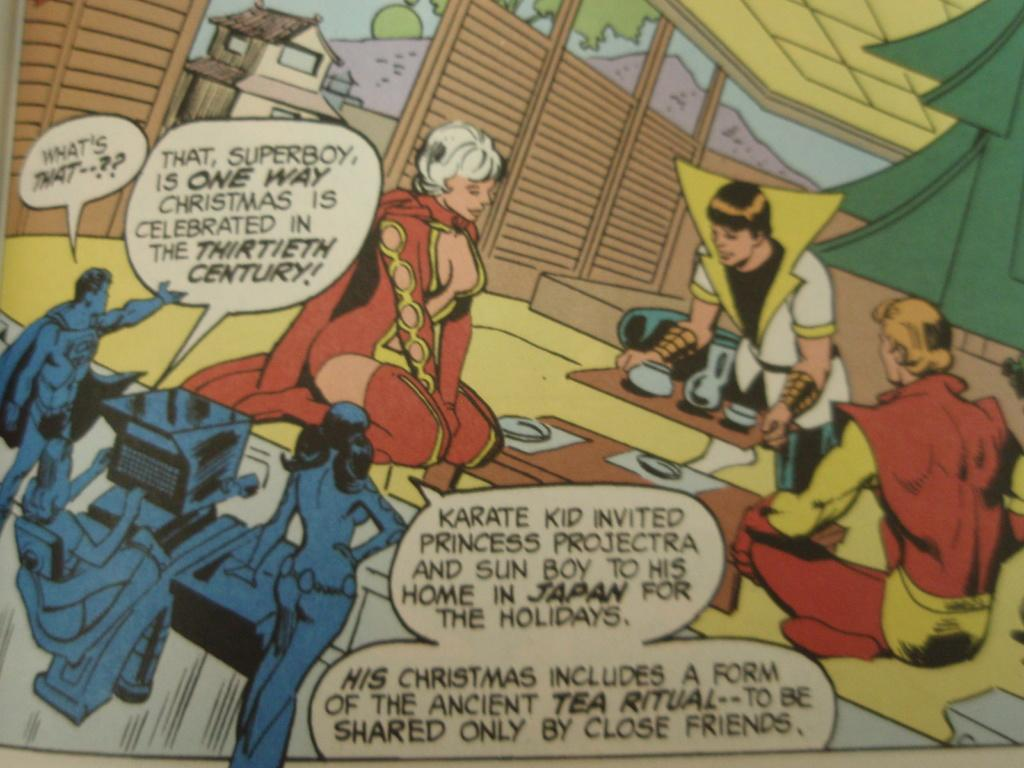<image>
Write a terse but informative summary of the picture. the word karate that is in a comic book 